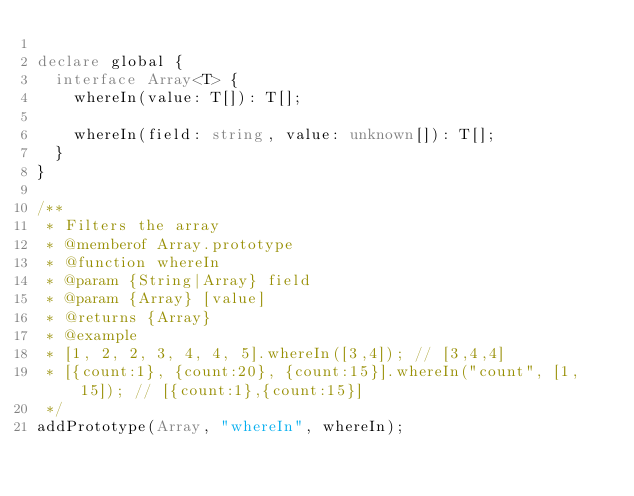Convert code to text. <code><loc_0><loc_0><loc_500><loc_500><_TypeScript_>
declare global {
  interface Array<T> {
    whereIn(value: T[]): T[];

    whereIn(field: string, value: unknown[]): T[];
  }
}

/**
 * Filters the array
 * @memberof Array.prototype
 * @function whereIn
 * @param {String|Array} field
 * @param {Array} [value]
 * @returns {Array}
 * @example
 * [1, 2, 2, 3, 4, 4, 5].whereIn([3,4]); // [3,4,4]
 * [{count:1}, {count:20}, {count:15}].whereIn("count", [1, 15]); // [{count:1},{count:15}]
 */
addPrototype(Array, "whereIn", whereIn);
</code> 